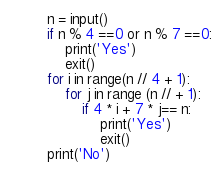<code> <loc_0><loc_0><loc_500><loc_500><_Python_>n = input()
if n % 4 ==0 or n % 7 ==0:
    print('Yes')
    exit()
for i in range(n // 4 + 1):
    for j in range (n // + 1):
        if 4 * i + 7 * j== n:
            print('Yes')
            exit()
print('No')</code> 